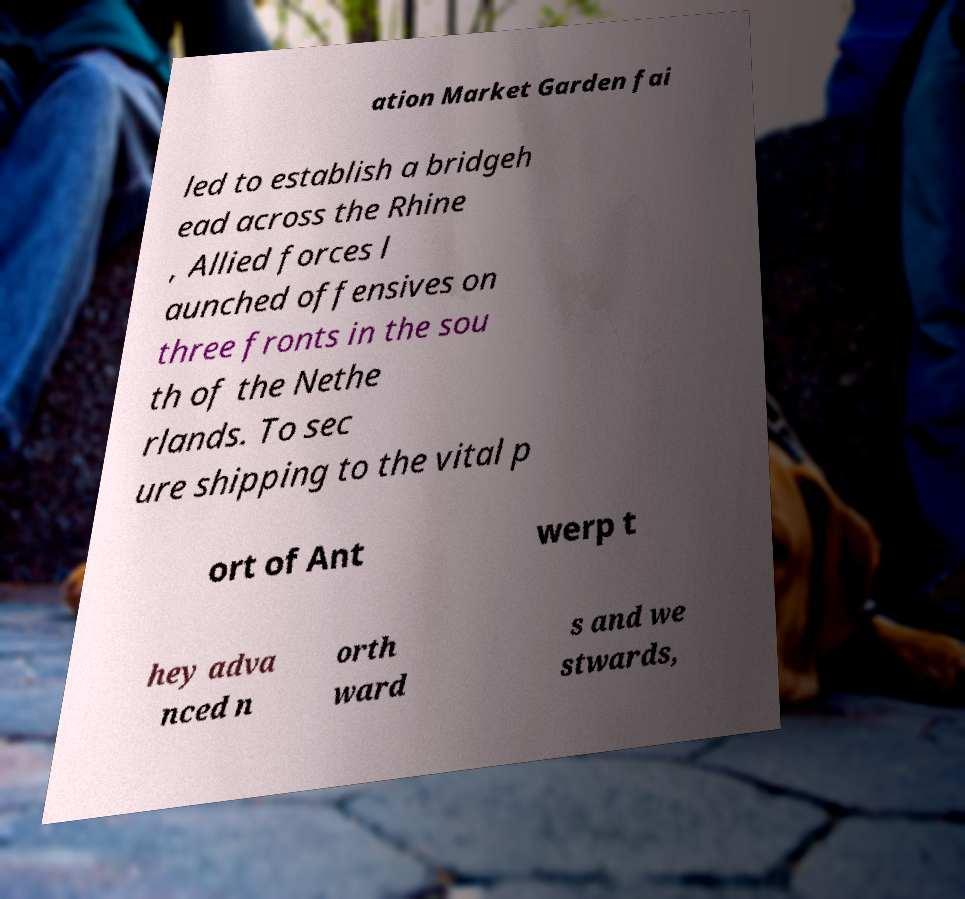Please identify and transcribe the text found in this image. ation Market Garden fai led to establish a bridgeh ead across the Rhine , Allied forces l aunched offensives on three fronts in the sou th of the Nethe rlands. To sec ure shipping to the vital p ort of Ant werp t hey adva nced n orth ward s and we stwards, 